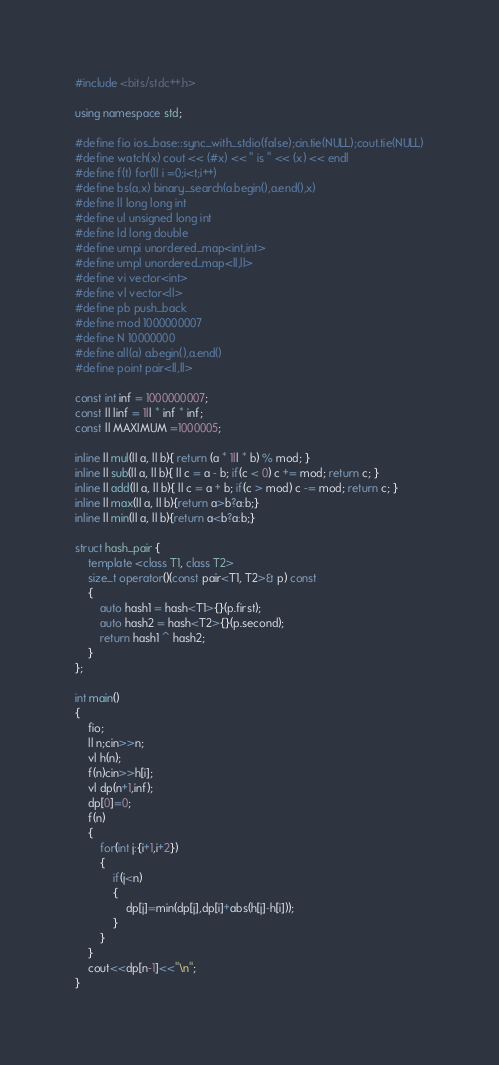<code> <loc_0><loc_0><loc_500><loc_500><_C++_>#include <bits/stdc++.h>

using namespace std;

#define fio ios_base::sync_with_stdio(false);cin.tie(NULL);cout.tie(NULL)
#define watch(x) cout << (#x) << " is " << (x) << endl
#define f(t) for(ll i =0;i<t;i++)
#define bs(a,x) binary_search(a.begin(),a.end(),x)
#define ll long long int
#define ul unsigned long int
#define ld long double
#define umpi unordered_map<int,int> 
#define umpl unordered_map<ll,ll> 
#define vi vector<int>
#define vl vector<ll>
#define pb push_back
#define mod 1000000007 
#define N 10000000
#define all(a) a.begin(),a.end()
#define point pair<ll,ll>

const int inf = 1000000007;
const ll linf = 1ll * inf * inf;
const ll MAXIMUM =1000005;

inline ll mul(ll a, ll b){ return (a * 1ll * b) % mod; }
inline ll sub(ll a, ll b){ ll c = a - b; if(c < 0) c += mod; return c; }
inline ll add(ll a, ll b){ ll c = a + b; if(c > mod) c -= mod; return c; }
inline ll max(ll a, ll b){return a>b?a:b;}
inline ll min(ll a, ll b){return a<b?a:b;}

struct hash_pair { 
    template <class T1, class T2> 
    size_t operator()(const pair<T1, T2>& p) const
    { 
        auto hash1 = hash<T1>{}(p.first); 
        auto hash2 = hash<T2>{}(p.second); 
        return hash1 ^ hash2; 
    } 
};

int main()
{
	fio;
	ll n;cin>>n;
	vl h(n);
	f(n)cin>>h[i];
	vl dp(n+1,inf);
	dp[0]=0;
	f(n)
	{
		for(int j:{i+1,i+2})
		{
			if(j<n)
			{
				dp[j]=min(dp[j],dp[i]+abs(h[j]-h[i]));
			}
		}
	}
	cout<<dp[n-1]<<"\n";
}</code> 